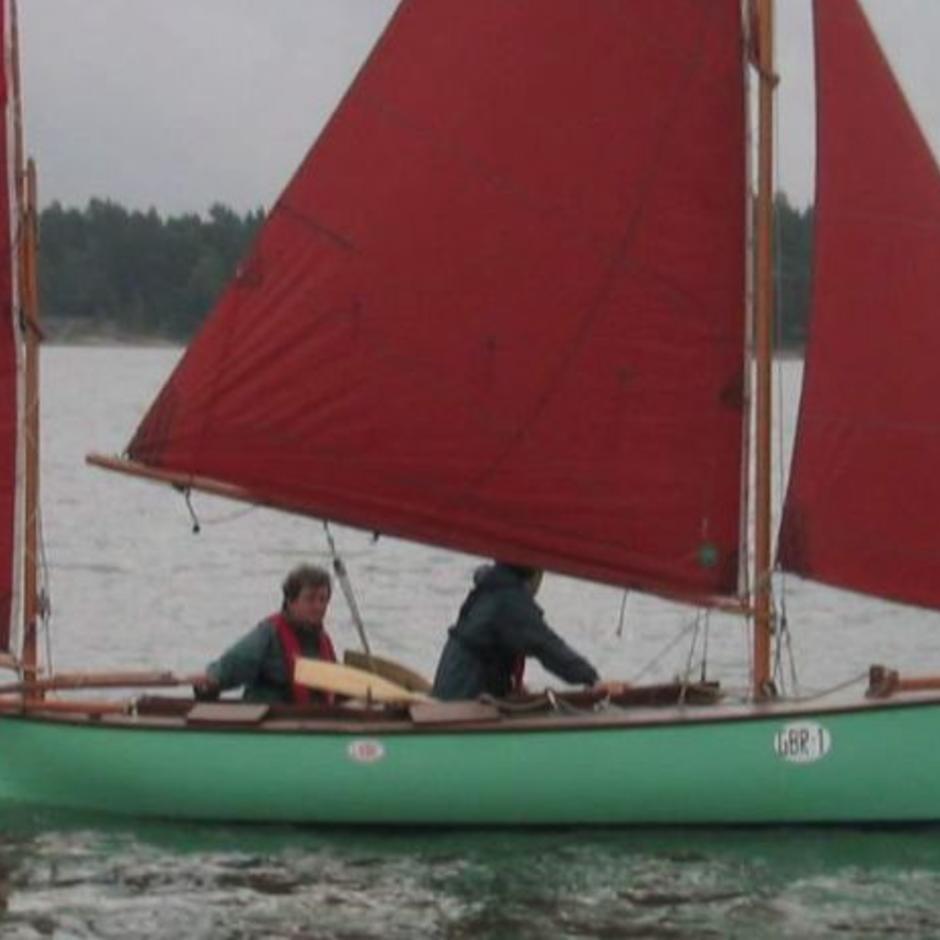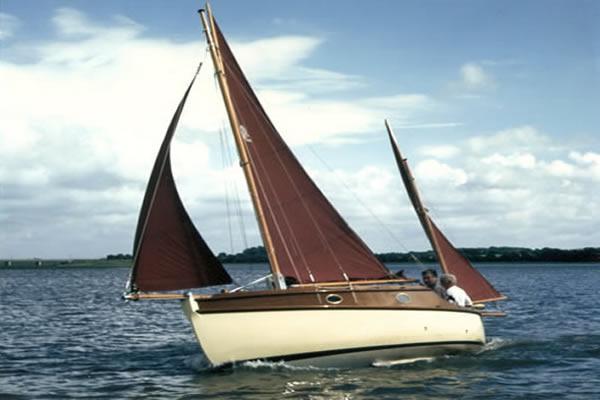The first image is the image on the left, the second image is the image on the right. Evaluate the accuracy of this statement regarding the images: "The left and right image contains the same number of sailboats with a dark open sails.". Is it true? Answer yes or no. Yes. The first image is the image on the left, the second image is the image on the right. Considering the images on both sides, is "The sailboats in the left and right images each have unfurled sails that are colored instead of white." valid? Answer yes or no. Yes. 